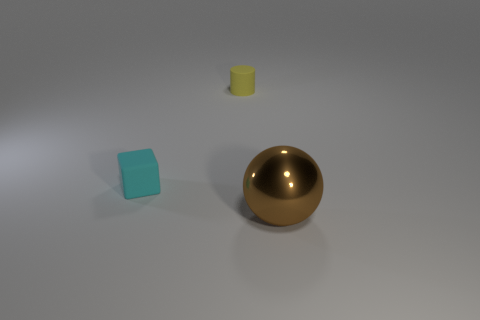Add 2 tiny objects. How many objects exist? 5 Subtract all blocks. How many objects are left? 2 Subtract 1 brown balls. How many objects are left? 2 Subtract all tiny blue cubes. Subtract all matte objects. How many objects are left? 1 Add 1 yellow cylinders. How many yellow cylinders are left? 2 Add 2 red matte balls. How many red matte balls exist? 2 